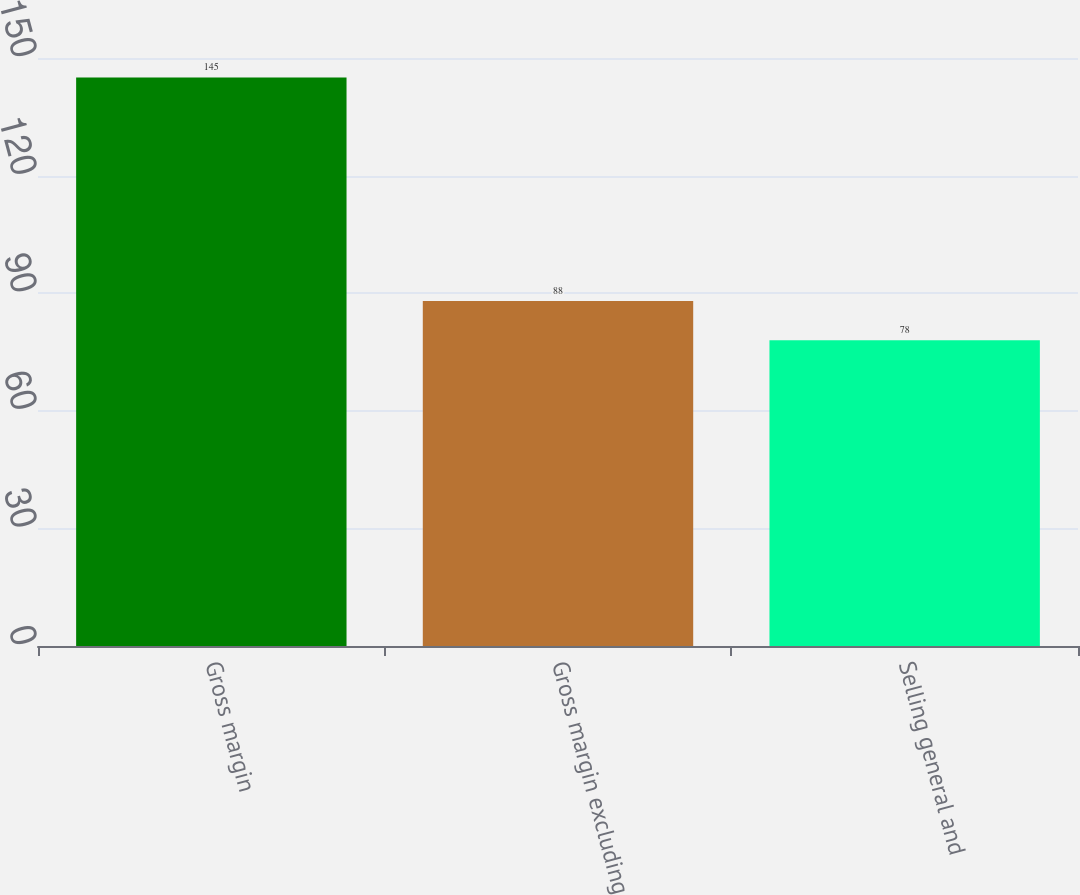<chart> <loc_0><loc_0><loc_500><loc_500><bar_chart><fcel>Gross margin<fcel>Gross margin excluding<fcel>Selling general and<nl><fcel>145<fcel>88<fcel>78<nl></chart> 